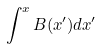Convert formula to latex. <formula><loc_0><loc_0><loc_500><loc_500>\int ^ { x } B ( x ^ { \prime } ) d x ^ { \prime }</formula> 